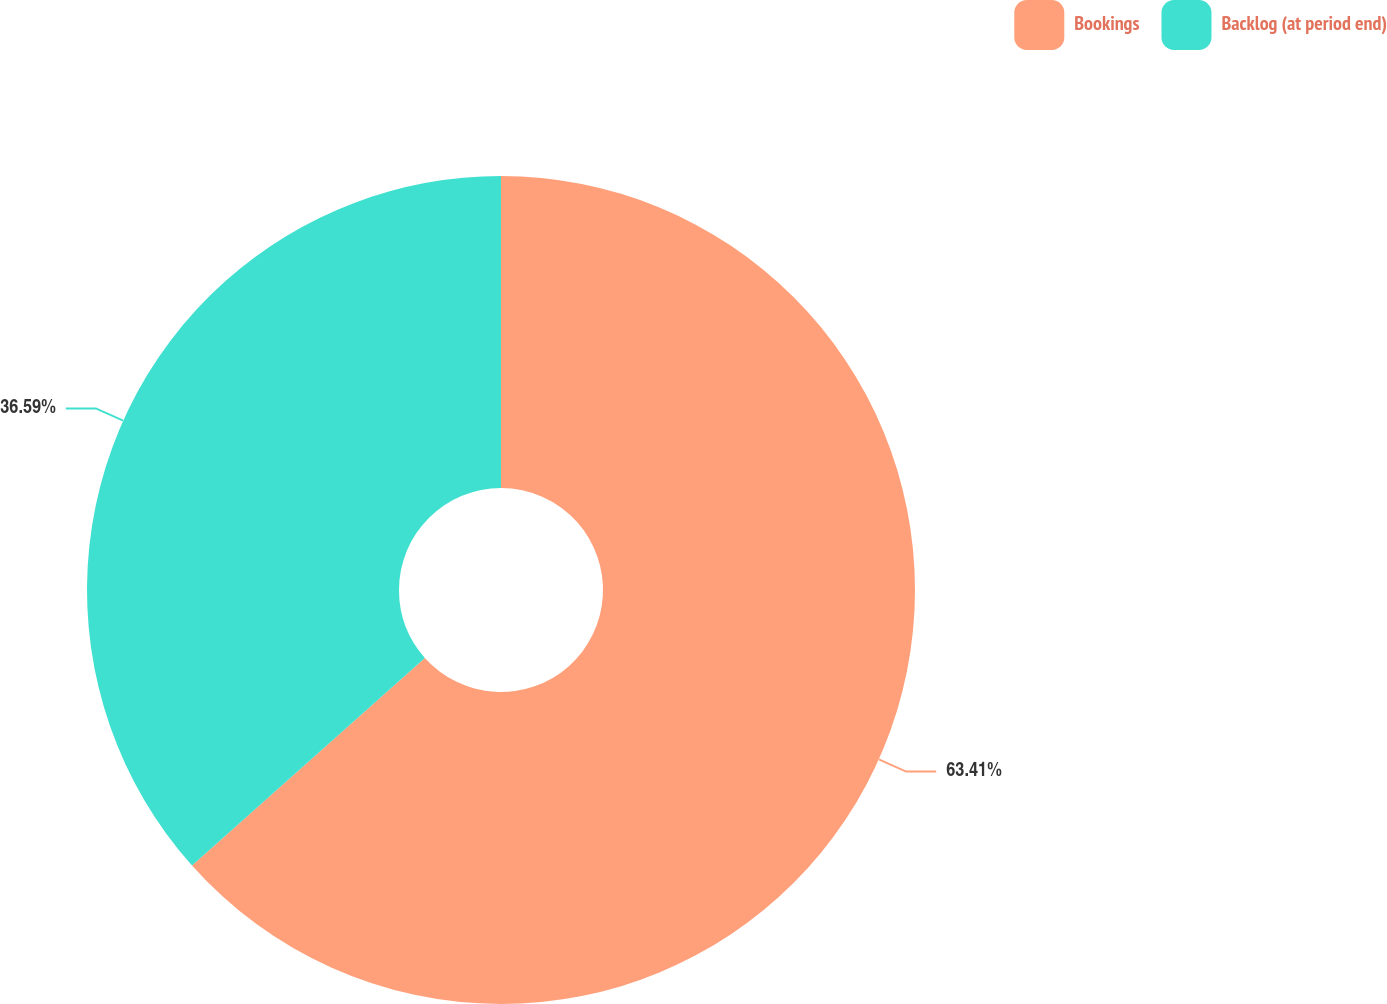<chart> <loc_0><loc_0><loc_500><loc_500><pie_chart><fcel>Bookings<fcel>Backlog (at period end)<nl><fcel>63.41%<fcel>36.59%<nl></chart> 